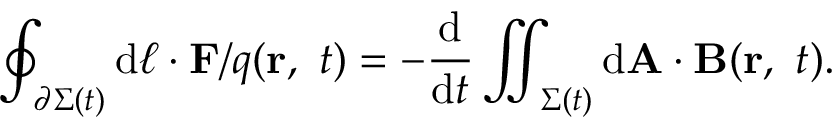Convert formula to latex. <formula><loc_0><loc_0><loc_500><loc_500>\oint _ { \partial \Sigma ( t ) } d { \ell } \cdot F / q ( r , \ t ) = - { \frac { d } { d t } } \iint _ { \Sigma ( t ) } d A \cdot B ( r , \ t ) .</formula> 